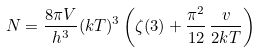Convert formula to latex. <formula><loc_0><loc_0><loc_500><loc_500>N = \frac { 8 \pi V } { h ^ { 3 } } ( k T ) ^ { 3 } \left ( \zeta ( 3 ) + \frac { \pi ^ { 2 } } { 1 2 } \, \frac { v } { 2 k T } \right )</formula> 